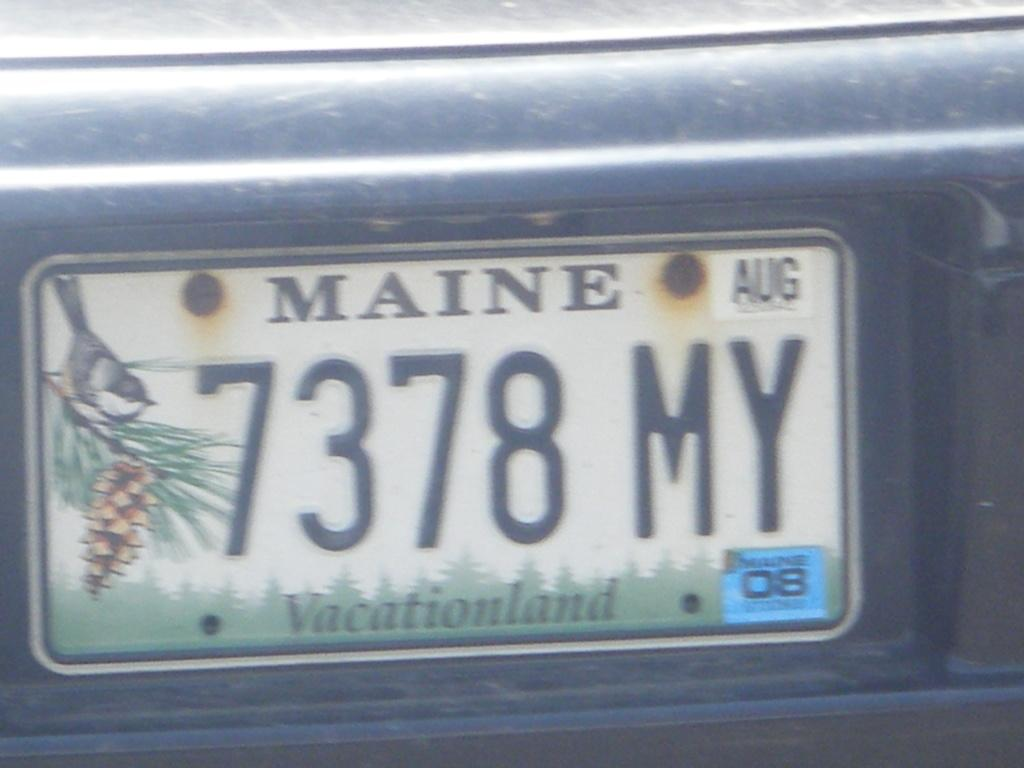<image>
Offer a succinct explanation of the picture presented. A license plate says Maine and the plate number is 7378 MY. 